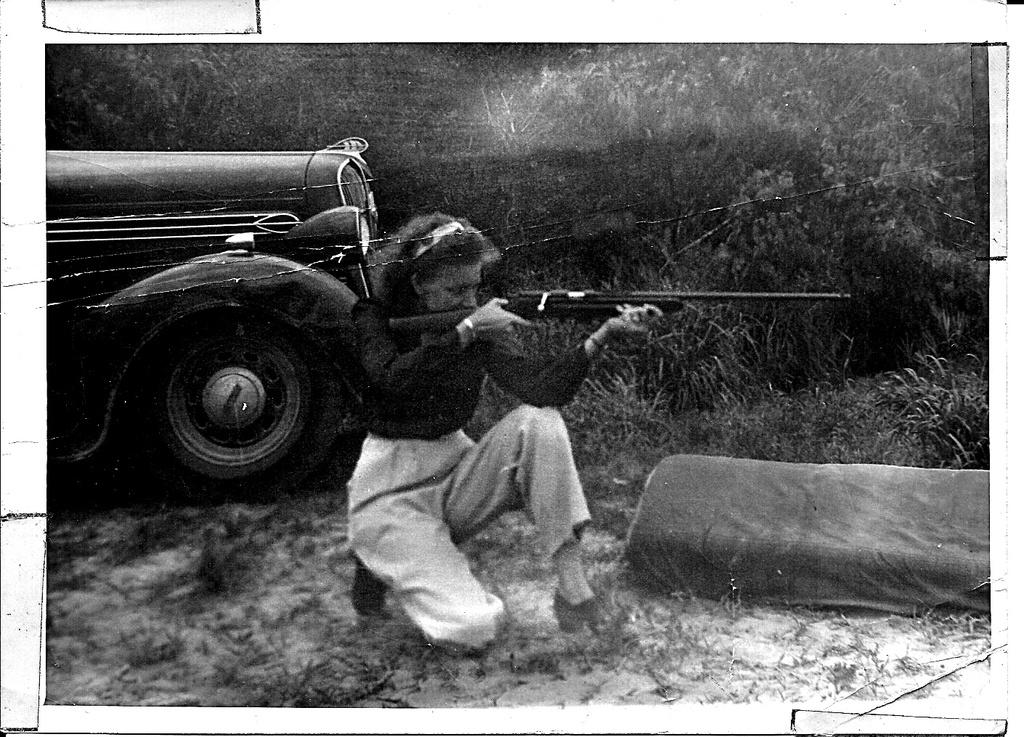What is the color scheme of the image? The image is black and white. Who is present in the image? There is a woman in the image. What is the woman holding? The woman is holding a gun. What else can be seen in the image? There is a vehicle, plants, cloth, and trees in the background of the image. What type of calculator can be seen on the woman's thumb in the image? There is no calculator or thumb visible in the image; it is a black and white image featuring a woman holding a gun. 